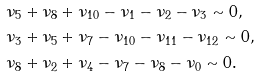Convert formula to latex. <formula><loc_0><loc_0><loc_500><loc_500>& \nu _ { 5 } + \nu _ { 8 } + \nu _ { 1 0 } - \nu _ { 1 } - \nu _ { 2 } - \nu _ { 3 } \sim 0 , \\ & \nu _ { 3 } + \nu _ { 5 } + \nu _ { 7 } - \nu _ { 1 0 } - \nu _ { 1 1 } - \nu _ { 1 2 } \sim 0 , \\ & \nu _ { 8 } + \nu _ { 2 } + \nu _ { 4 } - \nu _ { 7 } - \nu _ { 8 } - \nu _ { 0 } \sim 0 .</formula> 